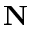Convert formula to latex. <formula><loc_0><loc_0><loc_500><loc_500>N</formula> 